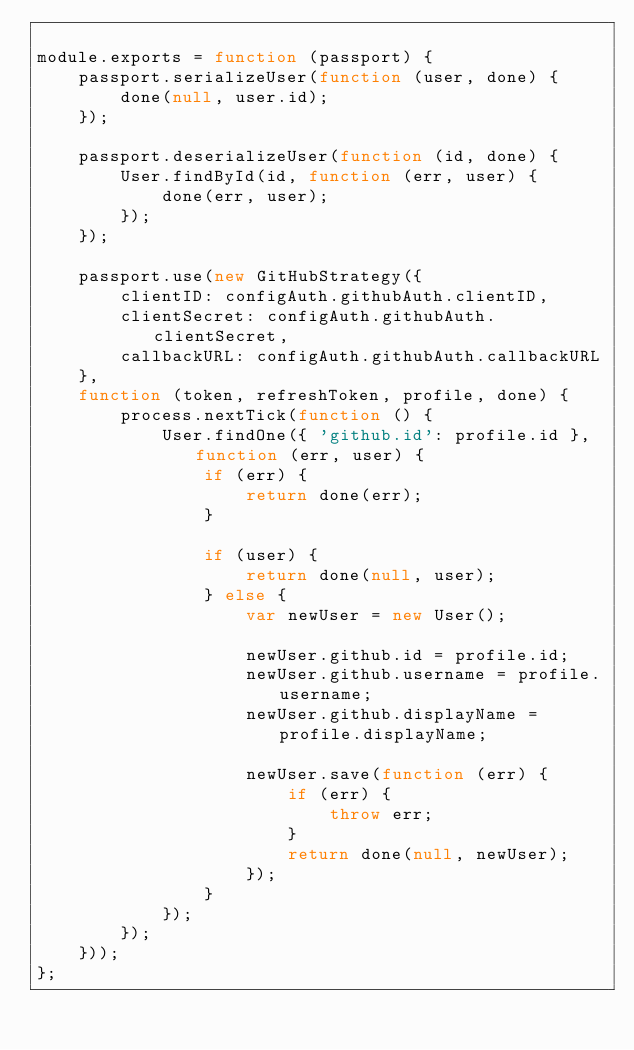Convert code to text. <code><loc_0><loc_0><loc_500><loc_500><_JavaScript_>
module.exports = function (passport) {
	passport.serializeUser(function (user, done) {
		done(null, user.id);
	});

	passport.deserializeUser(function (id, done) {
		User.findById(id, function (err, user) {
			done(err, user);
		});
	});

	passport.use(new GitHubStrategy({
		clientID: configAuth.githubAuth.clientID,
		clientSecret: configAuth.githubAuth.clientSecret,
		callbackURL: configAuth.githubAuth.callbackURL
	},
	function (token, refreshToken, profile, done) {
		process.nextTick(function () {
			User.findOne({ 'github.id': profile.id }, function (err, user) {
				if (err) {
					return done(err);
				}

				if (user) {
					return done(null, user);
				} else {
					var newUser = new User();

					newUser.github.id = profile.id;
					newUser.github.username = profile.username;
					newUser.github.displayName = profile.displayName;

					newUser.save(function (err) {
						if (err) {
							throw err;
						}
						return done(null, newUser);
					});
				}
			});
		});
	}));
};
</code> 